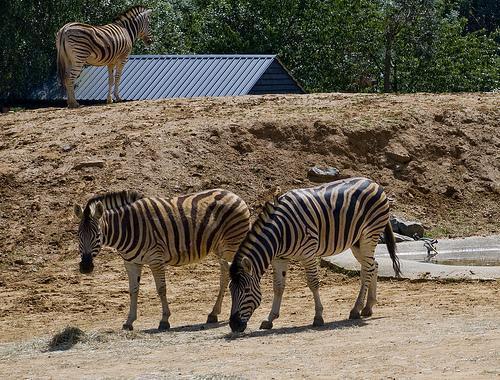How many zebras?
Give a very brief answer. 3. 